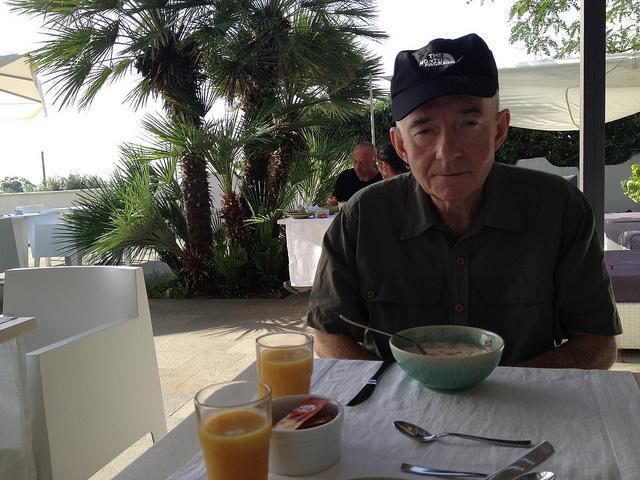How many bowls are there?
Give a very brief answer. 2. How many dining tables are in the picture?
Give a very brief answer. 2. How many chairs are in the photo?
Give a very brief answer. 2. How many cups can be seen?
Give a very brief answer. 2. How many trains are there?
Give a very brief answer. 0. 